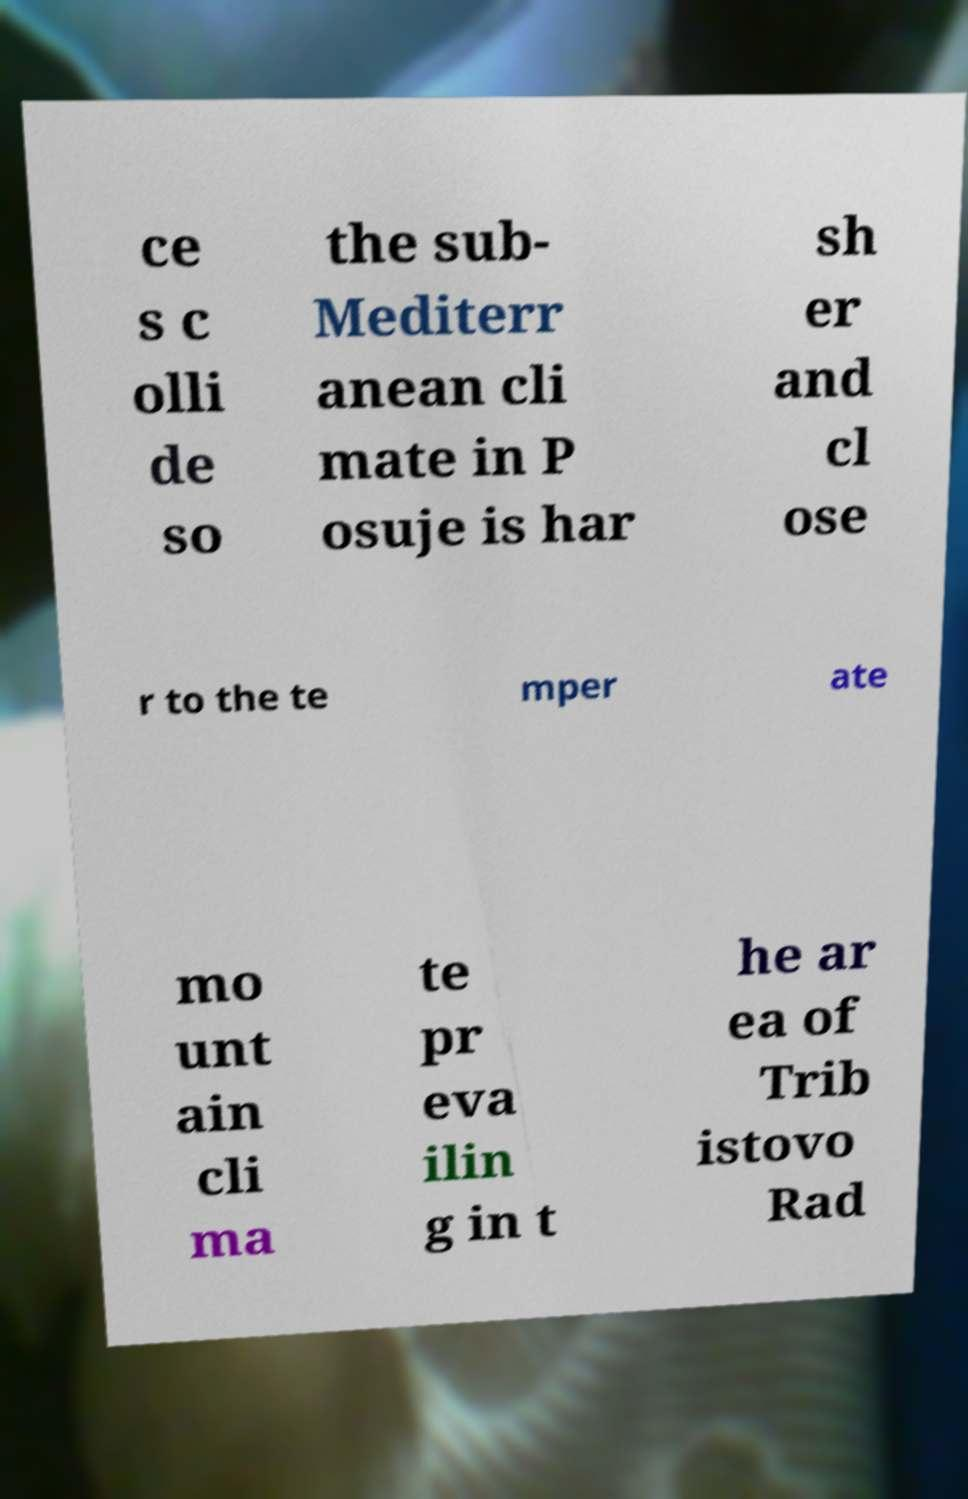Could you extract and type out the text from this image? ce s c olli de so the sub- Mediterr anean cli mate in P osuje is har sh er and cl ose r to the te mper ate mo unt ain cli ma te pr eva ilin g in t he ar ea of Trib istovo Rad 